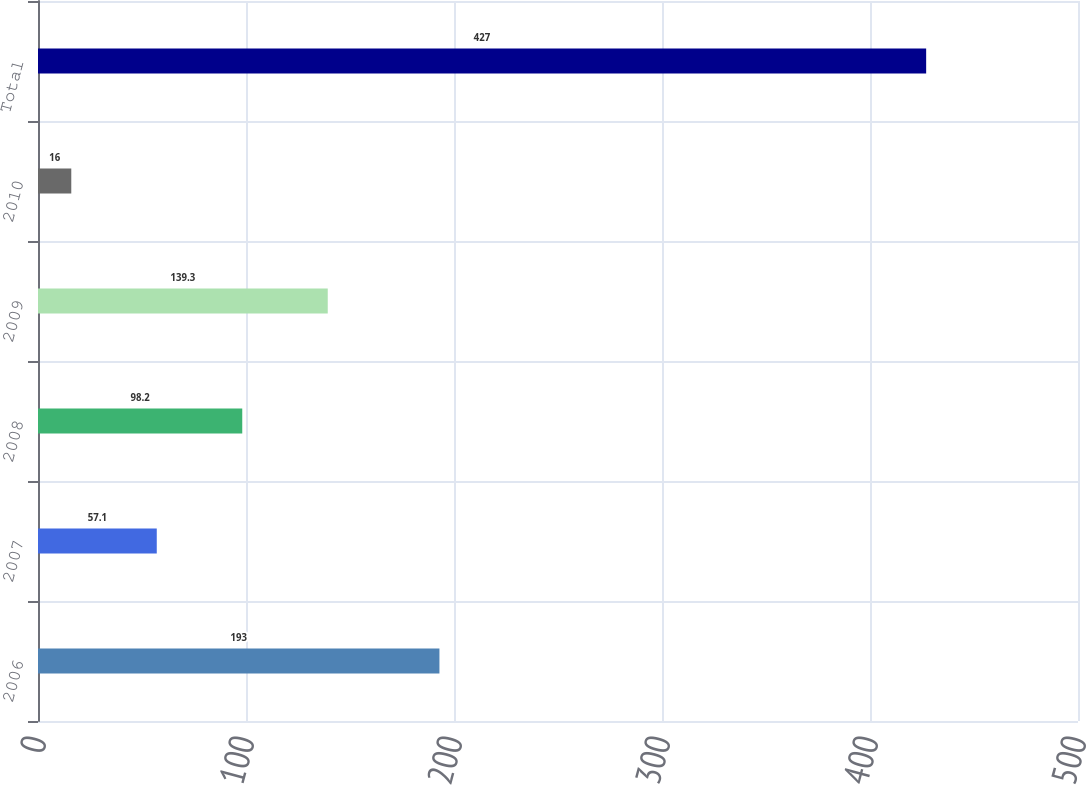Convert chart to OTSL. <chart><loc_0><loc_0><loc_500><loc_500><bar_chart><fcel>2006<fcel>2007<fcel>2008<fcel>2009<fcel>2010<fcel>Total<nl><fcel>193<fcel>57.1<fcel>98.2<fcel>139.3<fcel>16<fcel>427<nl></chart> 